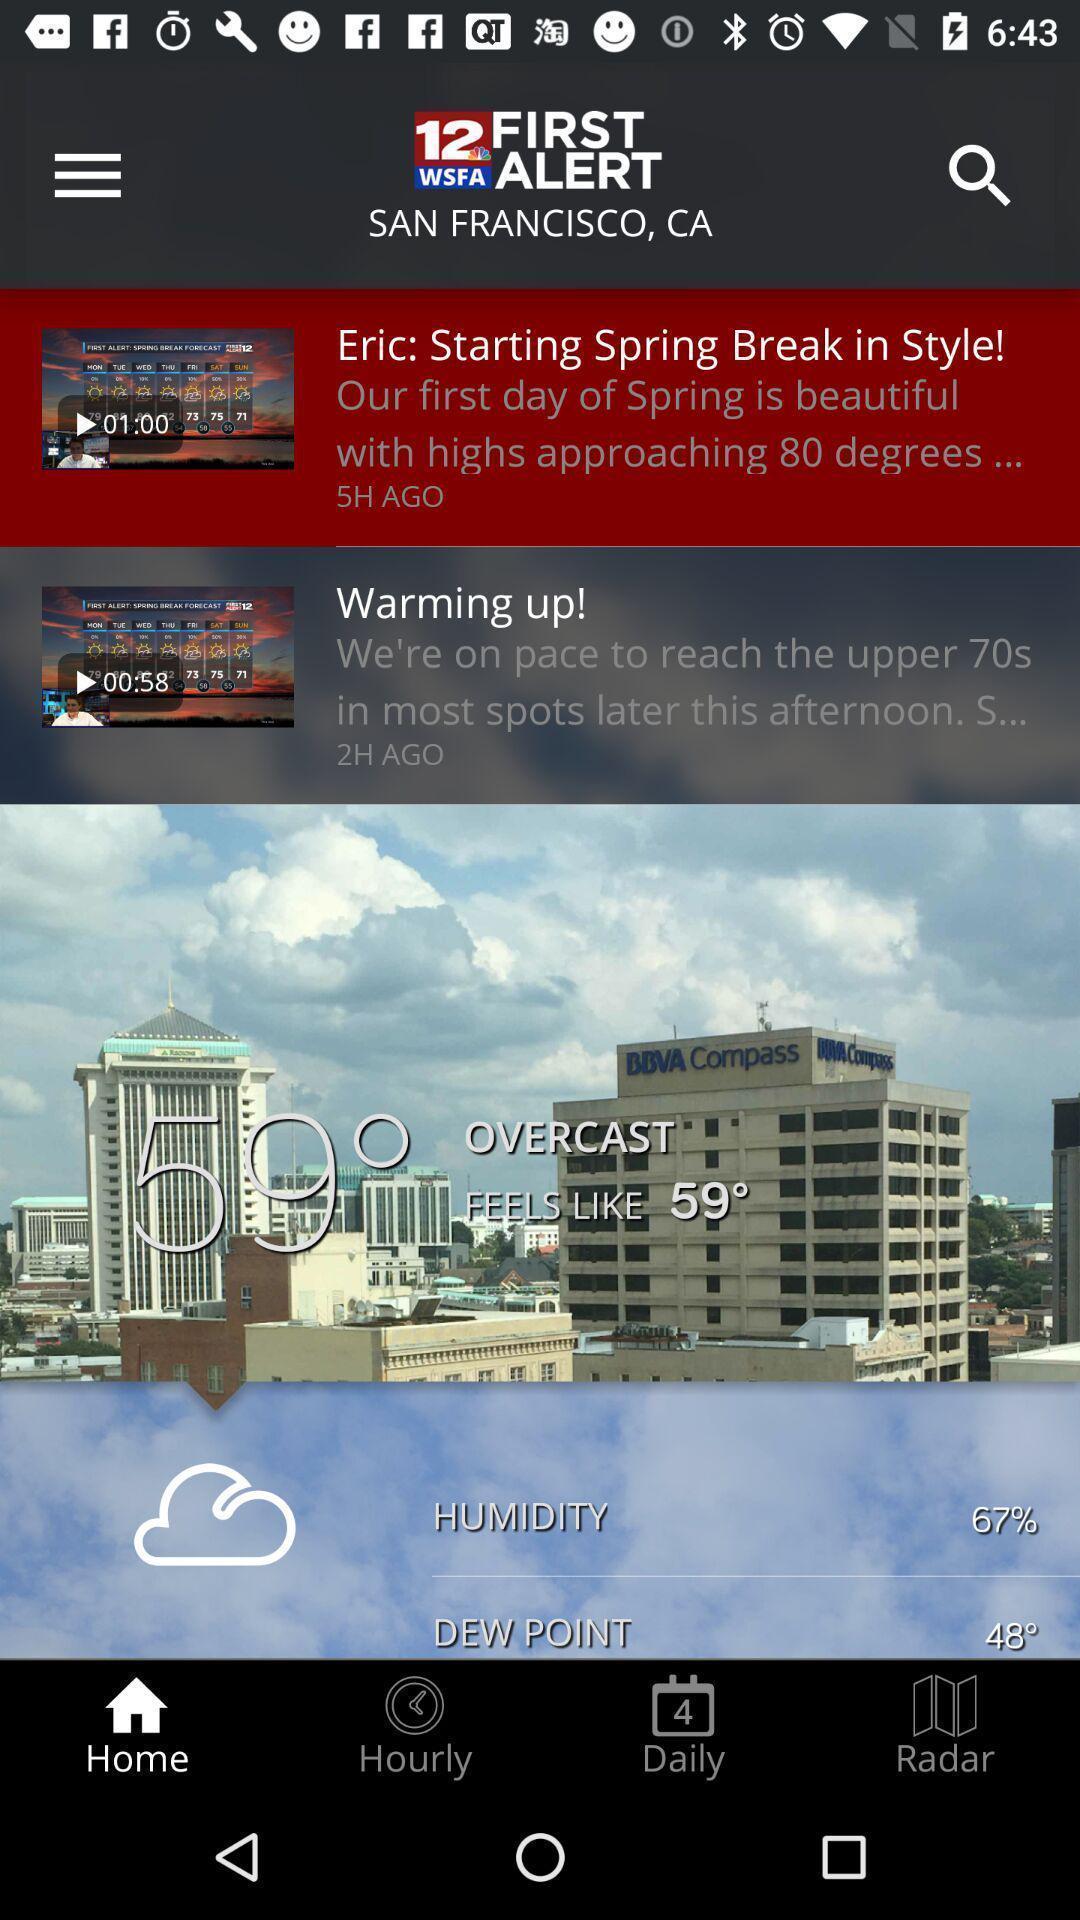Tell me what you see in this picture. Screen is showing home page. 